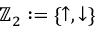Convert formula to latex. <formula><loc_0><loc_0><loc_500><loc_500>\mathbb { Z } _ { 2 } \colon = \{ \uparrow , \downarrow \}</formula> 